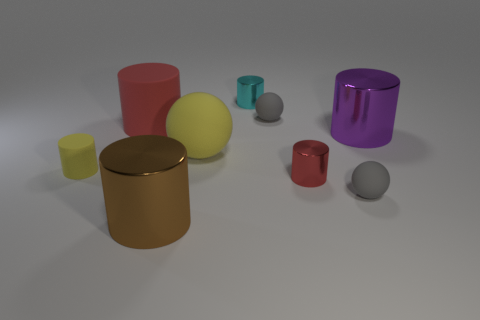Subtract all gray spheres. How many spheres are left? 1 Subtract all red cylinders. How many cylinders are left? 4 Subtract 2 cylinders. How many cylinders are left? 4 Subtract all big red rubber objects. Subtract all gray rubber things. How many objects are left? 6 Add 9 red matte things. How many red matte things are left? 10 Add 6 small gray objects. How many small gray objects exist? 8 Subtract 1 purple cylinders. How many objects are left? 8 Subtract all spheres. How many objects are left? 6 Subtract all cyan balls. Subtract all gray cylinders. How many balls are left? 3 Subtract all brown cylinders. How many red spheres are left? 0 